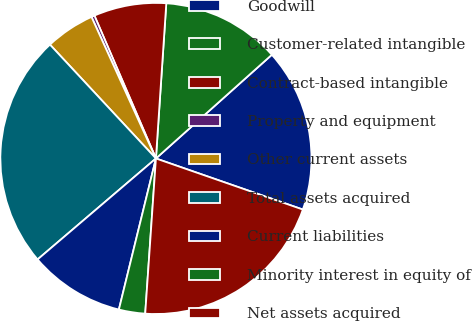Convert chart to OTSL. <chart><loc_0><loc_0><loc_500><loc_500><pie_chart><fcel>Goodwill<fcel>Customer-related intangible<fcel>Contract-based intangible<fcel>Property and equipment<fcel>Other current assets<fcel>Total assets acquired<fcel>Current liabilities<fcel>Minority interest in equity of<fcel>Net assets acquired<nl><fcel>16.94%<fcel>12.32%<fcel>7.53%<fcel>0.33%<fcel>5.13%<fcel>24.31%<fcel>9.93%<fcel>2.73%<fcel>20.77%<nl></chart> 